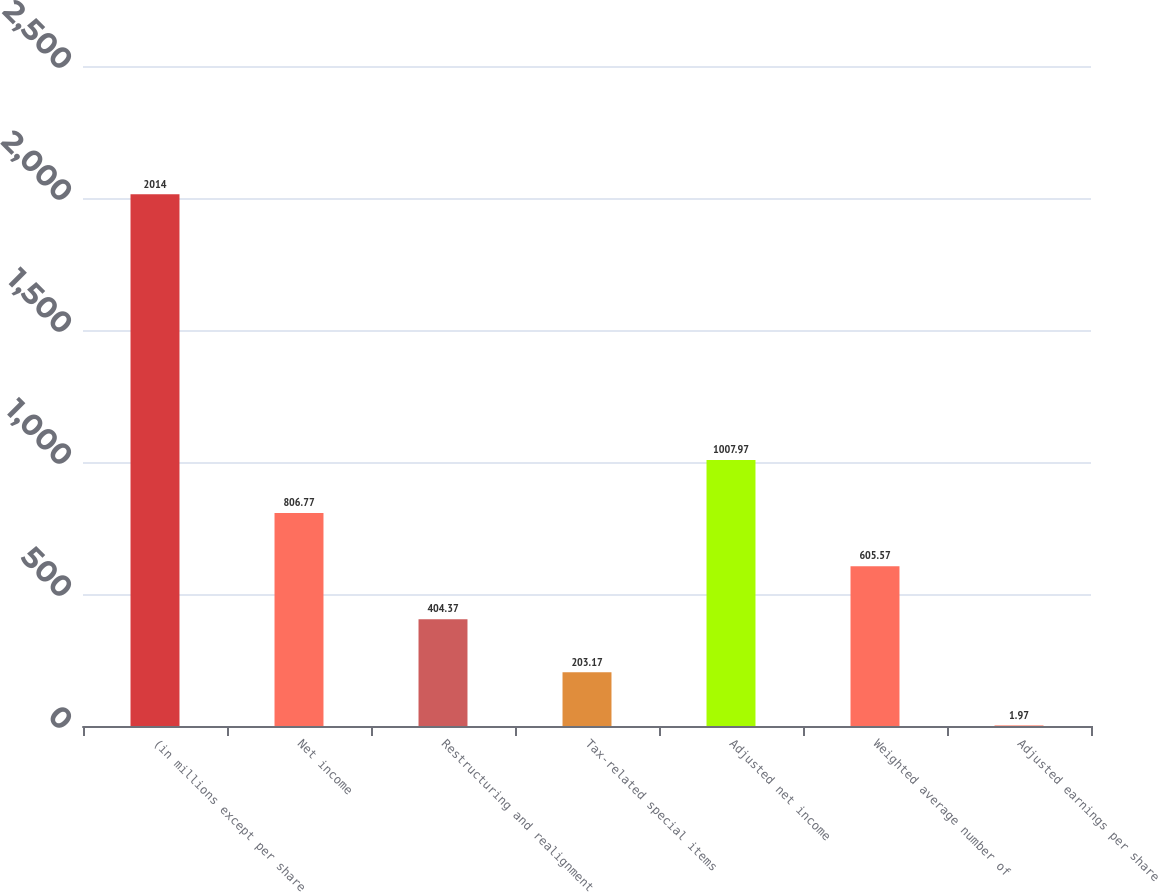Convert chart. <chart><loc_0><loc_0><loc_500><loc_500><bar_chart><fcel>(in millions except per share<fcel>Net income<fcel>Restructuring and realignment<fcel>Tax-related special items<fcel>Adjusted net income<fcel>Weighted average number of<fcel>Adjusted earnings per share<nl><fcel>2014<fcel>806.77<fcel>404.37<fcel>203.17<fcel>1007.97<fcel>605.57<fcel>1.97<nl></chart> 